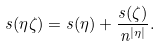<formula> <loc_0><loc_0><loc_500><loc_500>s ( \eta \zeta ) = s ( \eta ) + \frac { s ( \zeta ) } { n ^ { | \eta | } } .</formula> 